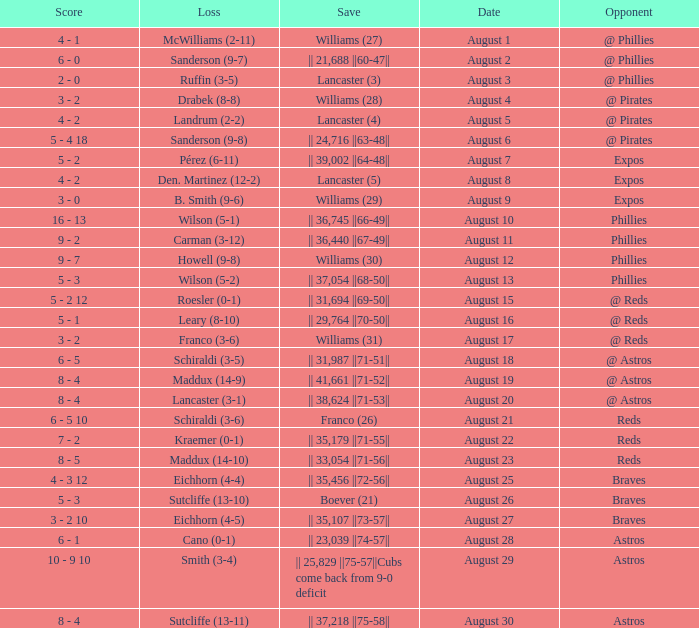Parse the full table. {'header': ['Score', 'Loss', 'Save', 'Date', 'Opponent'], 'rows': [['4 - 1', 'McWilliams (2-11)', 'Williams (27)', 'August 1', '@ Phillies'], ['6 - 0', 'Sanderson (9-7)', '|| 21,688 ||60-47||', 'August 2', '@ Phillies'], ['2 - 0', 'Ruffin (3-5)', 'Lancaster (3)', 'August 3', '@ Phillies'], ['3 - 2', 'Drabek (8-8)', 'Williams (28)', 'August 4', '@ Pirates'], ['4 - 2', 'Landrum (2-2)', 'Lancaster (4)', 'August 5', '@ Pirates'], ['5 - 4 18', 'Sanderson (9-8)', '|| 24,716 ||63-48||', 'August 6', '@ Pirates'], ['5 - 2', 'Pérez (6-11)', '|| 39,002 ||64-48||', 'August 7', 'Expos'], ['4 - 2', 'Den. Martinez (12-2)', 'Lancaster (5)', 'August 8', 'Expos'], ['3 - 0', 'B. Smith (9-6)', 'Williams (29)', 'August 9', 'Expos'], ['16 - 13', 'Wilson (5-1)', '|| 36,745 ||66-49||', 'August 10', 'Phillies'], ['9 - 2', 'Carman (3-12)', '|| 36,440 ||67-49||', 'August 11', 'Phillies'], ['9 - 7', 'Howell (9-8)', 'Williams (30)', 'August 12', 'Phillies'], ['5 - 3', 'Wilson (5-2)', '|| 37,054 ||68-50||', 'August 13', 'Phillies'], ['5 - 2 12', 'Roesler (0-1)', '|| 31,694 ||69-50||', 'August 15', '@ Reds'], ['5 - 1', 'Leary (8-10)', '|| 29,764 ||70-50||', 'August 16', '@ Reds'], ['3 - 2', 'Franco (3-6)', 'Williams (31)', 'August 17', '@ Reds'], ['6 - 5', 'Schiraldi (3-5)', '|| 31,987 ||71-51||', 'August 18', '@ Astros'], ['8 - 4', 'Maddux (14-9)', '|| 41,661 ||71-52||', 'August 19', '@ Astros'], ['8 - 4', 'Lancaster (3-1)', '|| 38,624 ||71-53||', 'August 20', '@ Astros'], ['6 - 5 10', 'Schiraldi (3-6)', 'Franco (26)', 'August 21', 'Reds'], ['7 - 2', 'Kraemer (0-1)', '|| 35,179 ||71-55||', 'August 22', 'Reds'], ['8 - 5', 'Maddux (14-10)', '|| 33,054 ||71-56||', 'August 23', 'Reds'], ['4 - 3 12', 'Eichhorn (4-4)', '|| 35,456 ||72-56||', 'August 25', 'Braves'], ['5 - 3', 'Sutcliffe (13-10)', 'Boever (21)', 'August 26', 'Braves'], ['3 - 2 10', 'Eichhorn (4-5)', '|| 35,107 ||73-57||', 'August 27', 'Braves'], ['6 - 1', 'Cano (0-1)', '|| 23,039 ||74-57||', 'August 28', 'Astros'], ['10 - 9 10', 'Smith (3-4)', '|| 25,829 ||75-57||Cubs come back from 9-0 deficit', 'August 29', 'Astros'], ['8 - 4', 'Sutcliffe (13-11)', '|| 37,218 ||75-58||', 'August 30', 'Astros']]} Name the opponent with loss of sanderson (9-8) @ Pirates. 